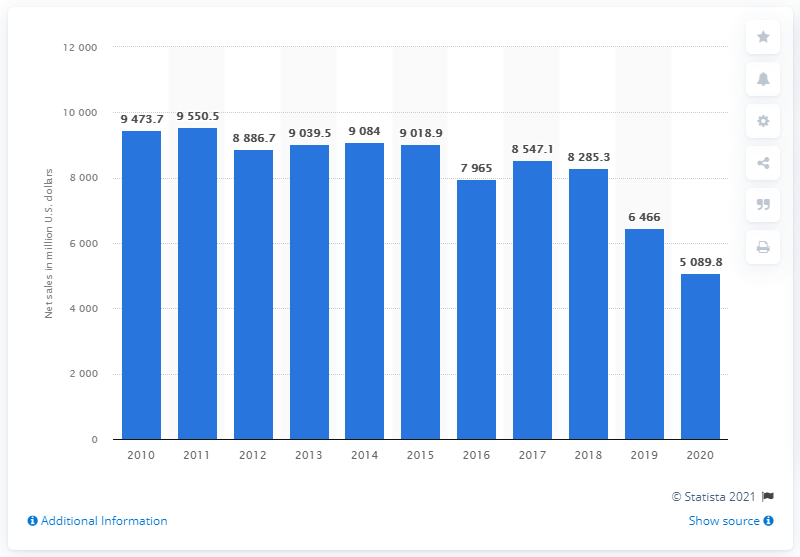Indicate a few pertinent items in this graphic. In 2020, GameStop's net sales were $5089.8 million. 